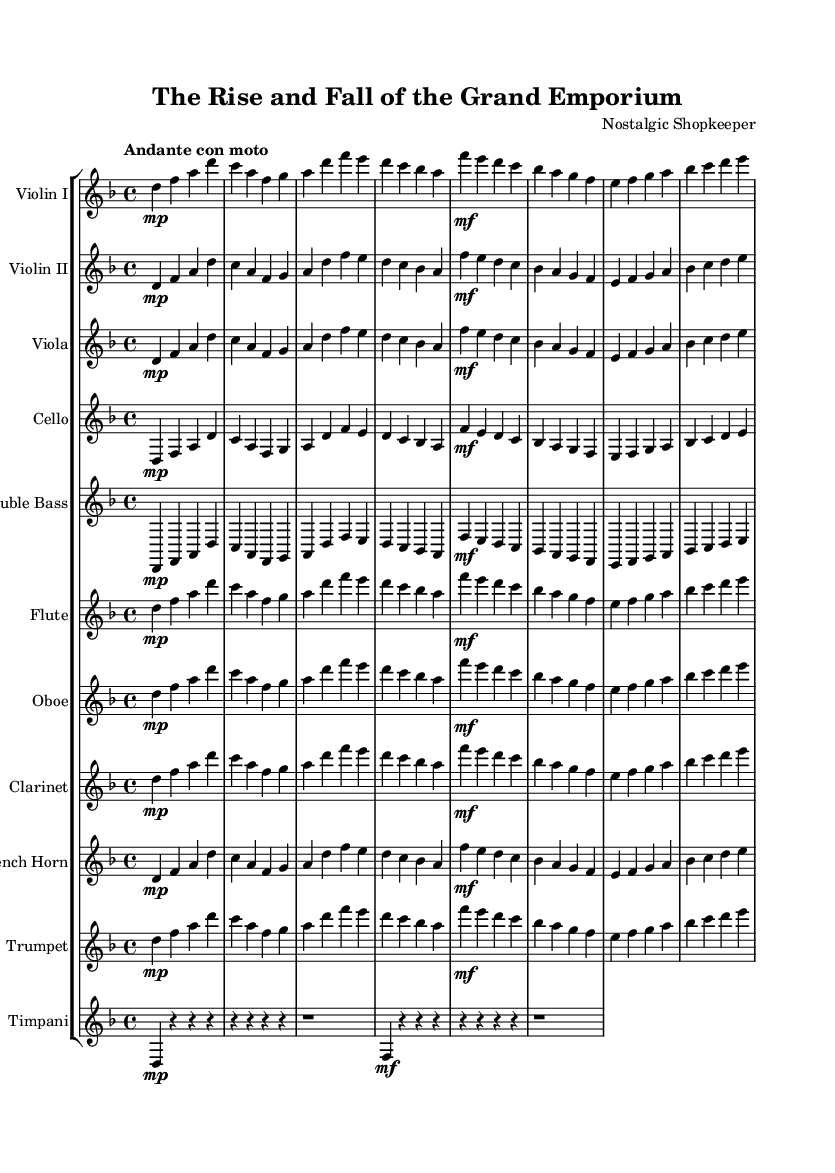What is the key signature of this music? The key signature is D minor, as indicated by one flat (B flat) in the key signature section of the sheet music.
Answer: D minor What is the time signature of this music? The time signature is 4/4, which is shown at the beginning of the score. This indicates there are four beats in each measure.
Answer: 4/4 What is the tempo marking of this piece? The tempo marking is "Andante con moto," which suggests a moderately slow speed with a bit of movement. This can be found in the tempo indication at the beginning of the score.
Answer: Andante con moto How many instruments are in this symphony? There are eleven instruments listed, as seen in the staff group section of the score. Each instrument is arranged on its own staff.
Answer: Eleven Describe the role of the timpani in this piece. The timpani part consists of rhythmic hits, indicated by the rests and the single quarter notes on a striking downbeat, providing a percussive anchor for the orchestra. This is interpreted from the rests and their placement in the score.
Answer: Rhythmic grounding What is the range of the double bass in this symphony? The double bass plays in the lower register and usually doubles the cello lines, as seen in the pitch range of the notes assigned for the double bass staff throughout the piece.
Answer: Lower register 